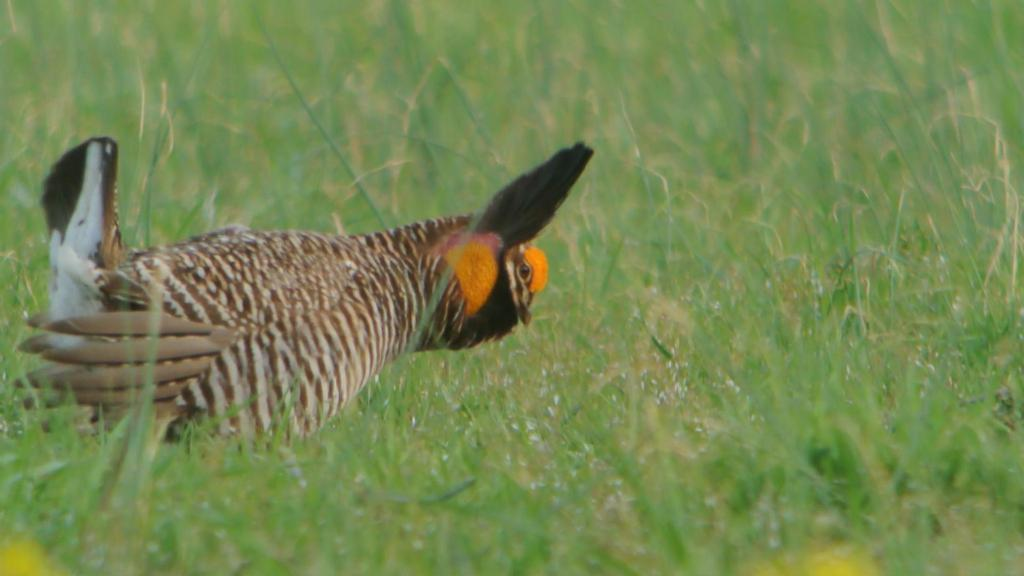What type of animal can be seen in the image? There is a bird in the image. Where is the bird located in the image? The bird is standing in the grass. What type of food is the bird eating in the image? There is no food visible in the image, and the bird is not shown eating anything. 